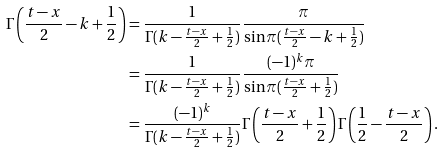Convert formula to latex. <formula><loc_0><loc_0><loc_500><loc_500>\Gamma \left ( \frac { t - x } { 2 } - k + \frac { 1 } { 2 } \right ) & = \frac { 1 } { \Gamma ( k - \frac { t - x } { 2 } + \frac { 1 } { 2 } ) } \frac { \pi } { \sin \pi ( \frac { t - x } { 2 } - k + \frac { 1 } { 2 } ) } \\ & = \frac { 1 } { \Gamma ( k - \frac { t - x } { 2 } + \frac { 1 } { 2 } ) } \frac { ( - 1 ) ^ { k } \pi } { \sin \pi ( \frac { t - x } { 2 } + \frac { 1 } { 2 } ) } \\ & = \frac { ( - 1 ) ^ { k } } { \Gamma ( k - \frac { t - x } { 2 } + \frac { 1 } { 2 } ) } \Gamma \left ( \frac { t - x } { 2 } + \frac { 1 } { 2 } \right ) \Gamma \left ( \frac { 1 } { 2 } - \frac { t - x } { 2 } \right ) .</formula> 